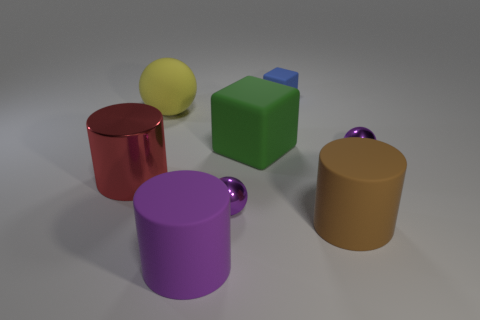Are there any other things of the same color as the large shiny cylinder?
Provide a succinct answer. No. What number of large gray metallic blocks are there?
Your answer should be compact. 0. What is the material of the sphere that is on the right side of the matte block on the right side of the big green cube?
Your response must be concise. Metal. What color is the small sphere to the left of the tiny shiny object that is on the right side of the tiny purple metallic ball that is in front of the red thing?
Provide a short and direct response. Purple. Is the tiny block the same color as the large cube?
Your response must be concise. No. How many brown cylinders have the same size as the rubber sphere?
Provide a succinct answer. 1. Are there more big brown rubber things that are left of the big red metallic thing than big blocks behind the tiny cube?
Make the answer very short. No. There is a small metal object in front of the sphere right of the big brown matte cylinder; what is its color?
Provide a short and direct response. Purple. Are the brown cylinder and the big yellow ball made of the same material?
Give a very brief answer. Yes. Are there any large purple shiny objects of the same shape as the blue object?
Keep it short and to the point. No. 